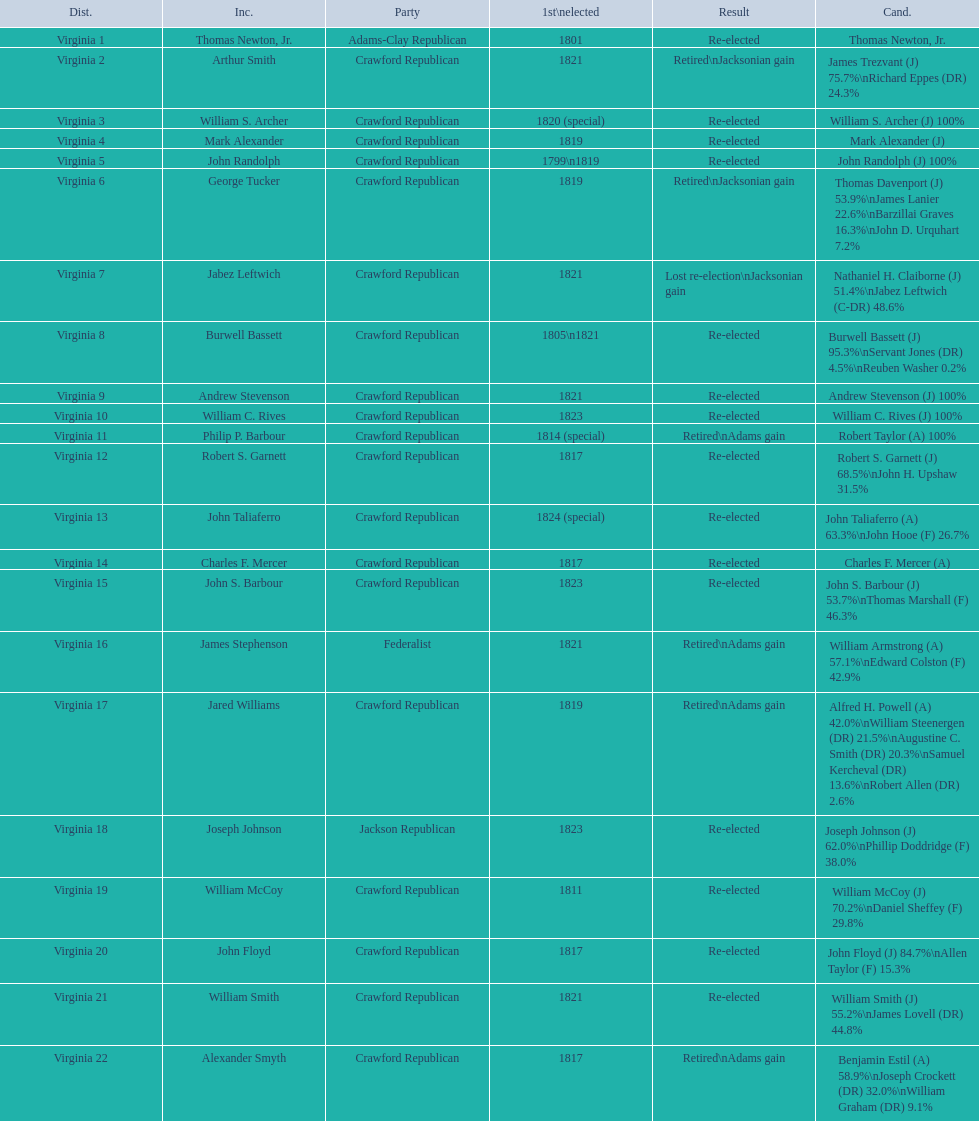How many candidates were there for virginia 17 district? 5. 